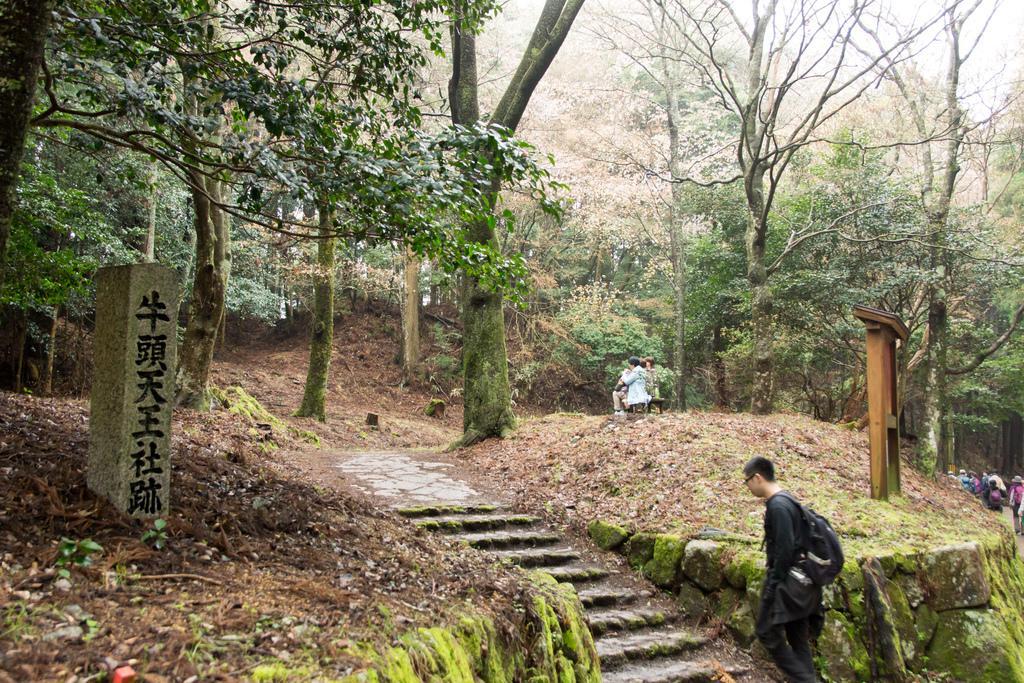Could you give a brief overview of what you see in this image? There is a person wearing specs and bag is walking on the steps. On the sides there are many trees. On the left side there is a pillar with something written on that. On the right side there is a wooden stand. Also there are many people. 